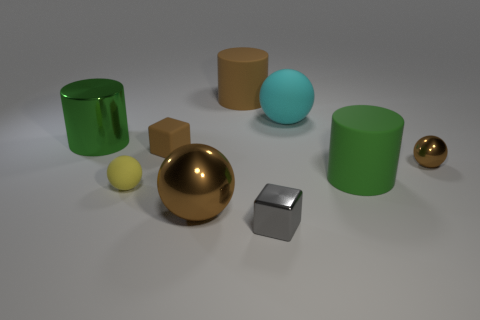There is a green thing to the left of the gray block; does it have the same size as the gray shiny object?
Your answer should be very brief. No. What is the color of the cylinder that is on the right side of the cube that is to the right of the big rubber cylinder behind the big metallic cylinder?
Offer a terse response. Green. What color is the small matte block?
Your response must be concise. Brown. Is the small metallic sphere the same color as the rubber block?
Your answer should be compact. Yes. Do the small brown thing that is in front of the tiny brown cube and the green object that is left of the gray thing have the same material?
Offer a very short reply. Yes. What is the material of the yellow thing that is the same shape as the big cyan rubber thing?
Ensure brevity in your answer.  Rubber. Is the material of the large brown cylinder the same as the small gray thing?
Provide a short and direct response. No. There is a tiny block to the left of the brown metal object that is in front of the yellow rubber thing; what color is it?
Offer a very short reply. Brown. What size is the green cylinder that is the same material as the cyan ball?
Provide a succinct answer. Large. What number of large matte objects are the same shape as the small gray object?
Give a very brief answer. 0. 